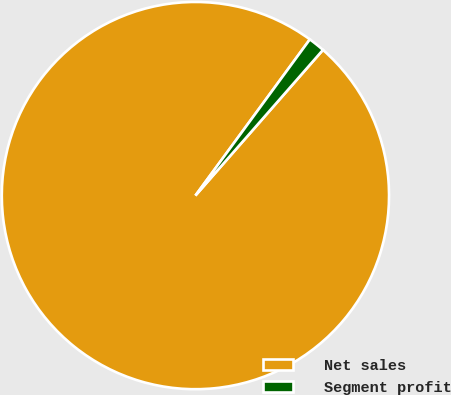Convert chart. <chart><loc_0><loc_0><loc_500><loc_500><pie_chart><fcel>Net sales<fcel>Segment profit<nl><fcel>98.62%<fcel>1.38%<nl></chart> 